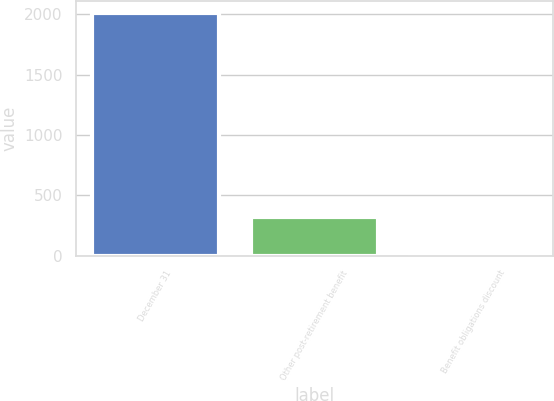<chart> <loc_0><loc_0><loc_500><loc_500><bar_chart><fcel>December 31<fcel>Other post-retirement benefit<fcel>Benefit obligations discount<nl><fcel>2009<fcel>324.6<fcel>5.7<nl></chart> 